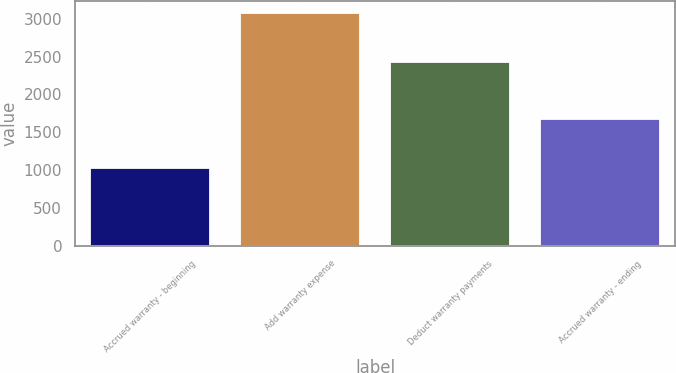Convert chart. <chart><loc_0><loc_0><loc_500><loc_500><bar_chart><fcel>Accrued warranty - beginning<fcel>Add warranty expense<fcel>Deduct warranty payments<fcel>Accrued warranty - ending<nl><fcel>1021<fcel>3080<fcel>2426<fcel>1675<nl></chart> 